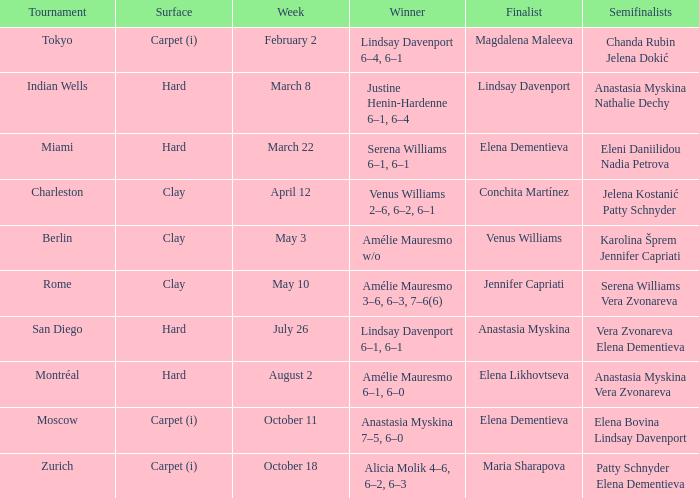Who were the four competitors that reached the semifinals in the rome tournament? Serena Williams Vera Zvonareva. 